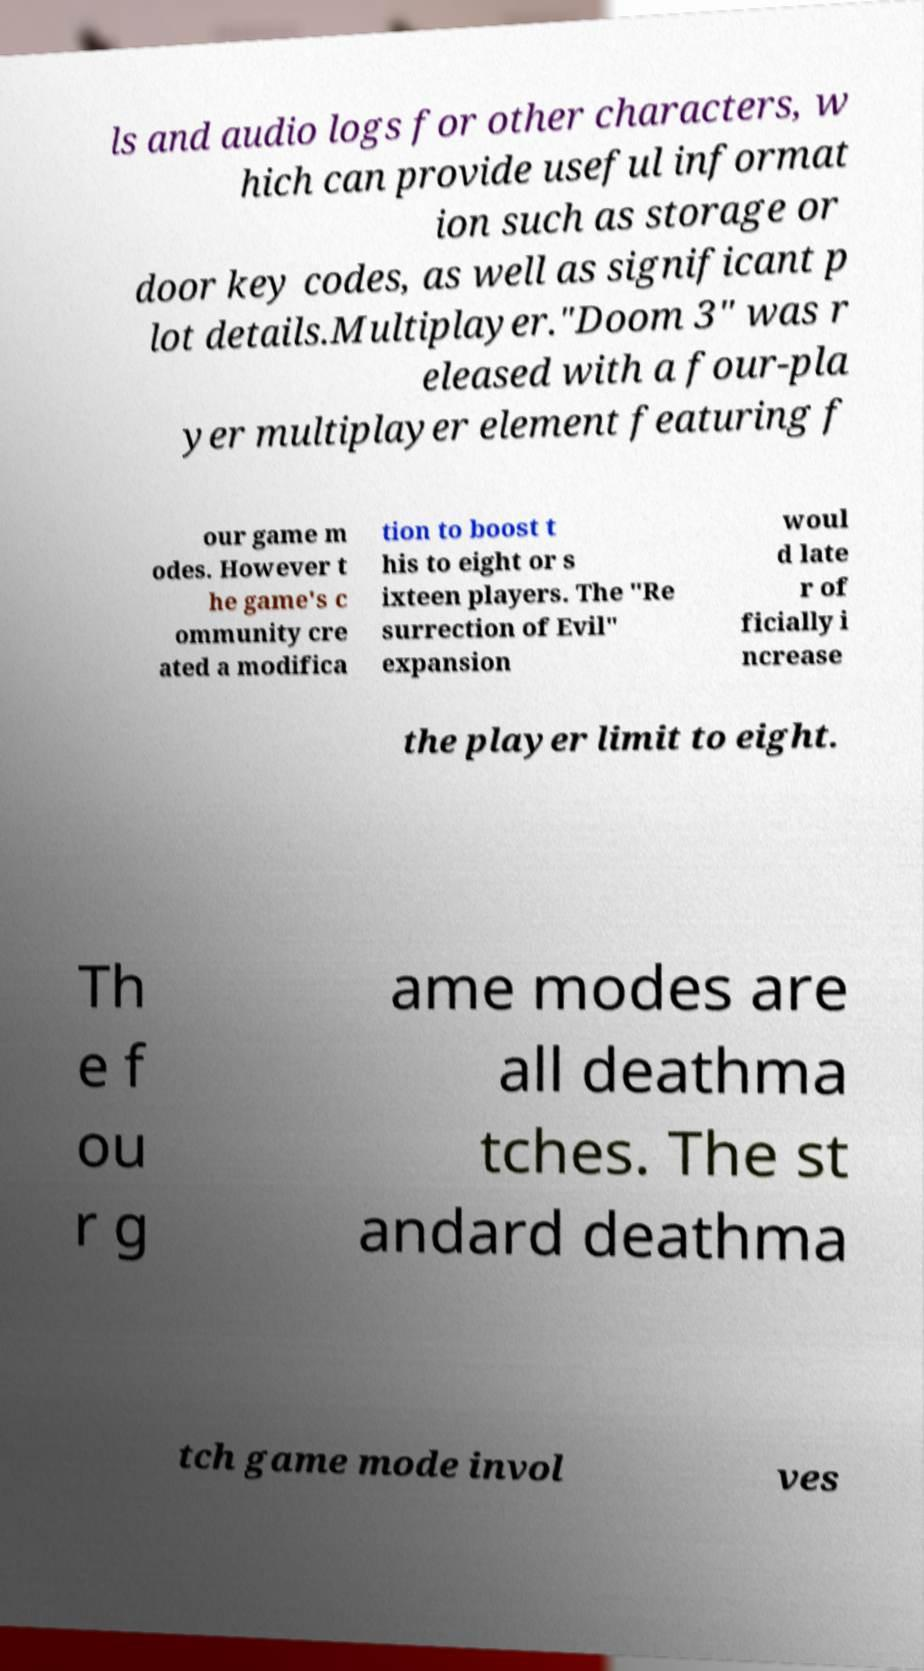I need the written content from this picture converted into text. Can you do that? ls and audio logs for other characters, w hich can provide useful informat ion such as storage or door key codes, as well as significant p lot details.Multiplayer."Doom 3" was r eleased with a four-pla yer multiplayer element featuring f our game m odes. However t he game's c ommunity cre ated a modifica tion to boost t his to eight or s ixteen players. The "Re surrection of Evil" expansion woul d late r of ficially i ncrease the player limit to eight. Th e f ou r g ame modes are all deathma tches. The st andard deathma tch game mode invol ves 